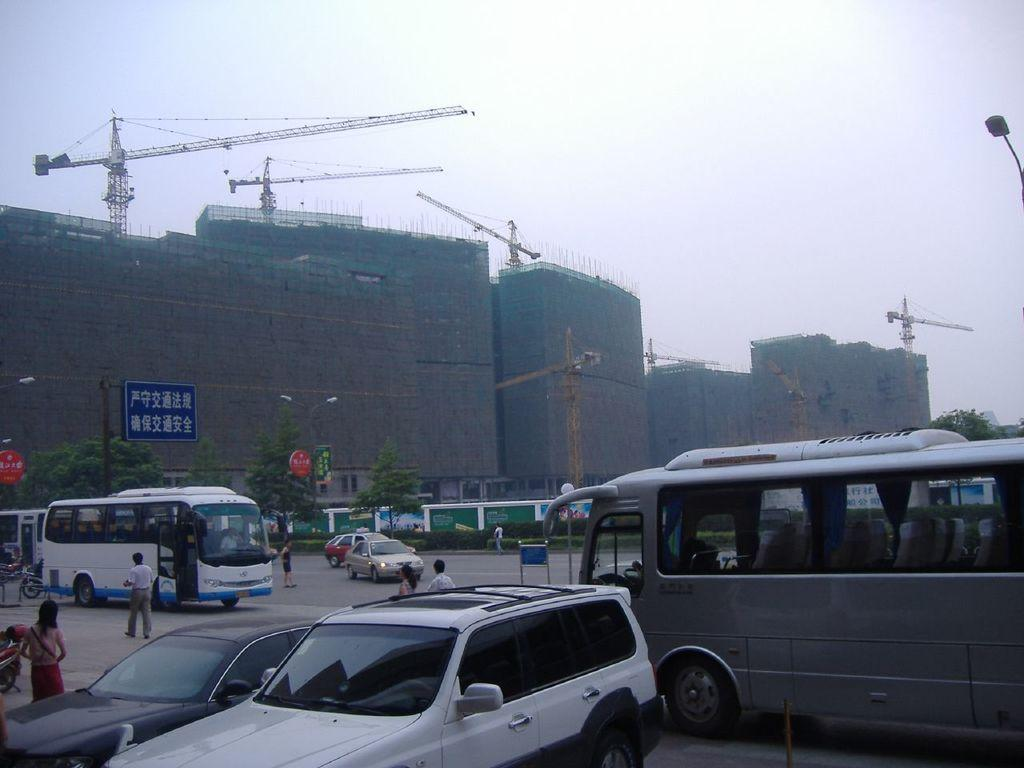What is happening to the buildings in the image? The buildings in the image are under construction. What machinery can be seen in the image? Cranes are present in the image. What can be seen in the sky in the image? The sky is visible in the image. What is happening on the road in the image? Vehicles are on the road in the image. What type of signage is present in the image? There are sign boards in the image. What type of vegetation is present in the image? Trees are present in the image. Who can be seen in the image? People are visible in the image. What type of pole is in the image? A light pole is in the image. What is on the building in the image? There is a blue board on a building in the image. What type of cord is being used to trip people in the image? There is no cord present in the image, nor is anyone being tripped. What time of day is depicted in the image? The time of day is not specified in the image. 